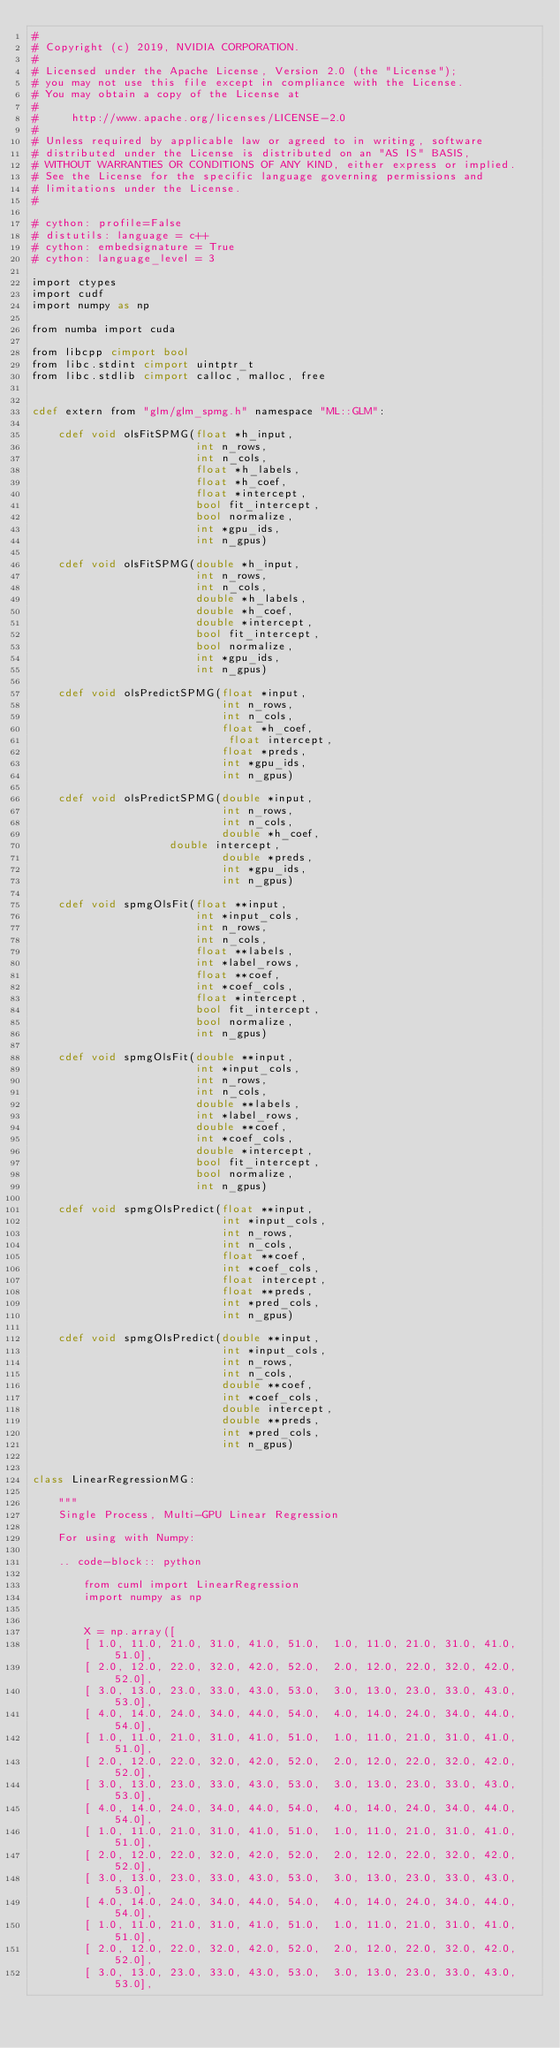<code> <loc_0><loc_0><loc_500><loc_500><_Cython_>#
# Copyright (c) 2019, NVIDIA CORPORATION.
#
# Licensed under the Apache License, Version 2.0 (the "License");
# you may not use this file except in compliance with the License.
# You may obtain a copy of the License at
#
#     http://www.apache.org/licenses/LICENSE-2.0
#
# Unless required by applicable law or agreed to in writing, software
# distributed under the License is distributed on an "AS IS" BASIS,
# WITHOUT WARRANTIES OR CONDITIONS OF ANY KIND, either express or implied.
# See the License for the specific language governing permissions and
# limitations under the License.
#

# cython: profile=False
# distutils: language = c++
# cython: embedsignature = True
# cython: language_level = 3

import ctypes
import cudf
import numpy as np

from numba import cuda

from libcpp cimport bool
from libc.stdint cimport uintptr_t
from libc.stdlib cimport calloc, malloc, free


cdef extern from "glm/glm_spmg.h" namespace "ML::GLM":

    cdef void olsFitSPMG(float *h_input,
                         int n_rows,
                         int n_cols,
                         float *h_labels,
                         float *h_coef,
                         float *intercept,
                         bool fit_intercept,
                         bool normalize,
                         int *gpu_ids,
                         int n_gpus)

    cdef void olsFitSPMG(double *h_input,
                         int n_rows,
                         int n_cols,
                         double *h_labels,
                         double *h_coef,
                         double *intercept,
                         bool fit_intercept,
                         bool normalize,
                         int *gpu_ids,
                         int n_gpus)

    cdef void olsPredictSPMG(float *input,
                             int n_rows,
                             int n_cols,
                             float *h_coef,
                              float intercept,
                             float *preds,
                             int *gpu_ids,
                             int n_gpus)

    cdef void olsPredictSPMG(double *input,
                             int n_rows,
                             int n_cols,
                             double *h_coef,
                     double intercept,
                             double *preds,
                             int *gpu_ids,
                             int n_gpus)

    cdef void spmgOlsFit(float **input,
                         int *input_cols,
                         int n_rows,
                         int n_cols,
                         float **labels,
                         int *label_rows,
                         float **coef,
                         int *coef_cols,
                         float *intercept,
                         bool fit_intercept,
                         bool normalize,
                         int n_gpus)

    cdef void spmgOlsFit(double **input,
                         int *input_cols,
                         int n_rows,
                         int n_cols,
                         double **labels,
                         int *label_rows,
                         double **coef,
                         int *coef_cols,
                         double *intercept,
                         bool fit_intercept,
                         bool normalize,
                         int n_gpus)

    cdef void spmgOlsPredict(float **input,
                             int *input_cols,
                             int n_rows,
                             int n_cols,
                             float **coef,
                             int *coef_cols,
                             float intercept,
                             float **preds,
                             int *pred_cols,
                             int n_gpus)

    cdef void spmgOlsPredict(double **input,
                             int *input_cols,
                             int n_rows,
                             int n_cols,
                             double **coef,
                             int *coef_cols,
                             double intercept,
                             double **preds,
                             int *pred_cols,
                             int n_gpus)


class LinearRegressionMG:

    """
    Single Process, Multi-GPU Linear Regression

    For using with Numpy:

    .. code-block:: python

        from cuml import LinearRegression
        import numpy as np


        X = np.array([
        [ 1.0, 11.0, 21.0, 31.0, 41.0, 51.0,  1.0, 11.0, 21.0, 31.0, 41.0, 51.0],
        [ 2.0, 12.0, 22.0, 32.0, 42.0, 52.0,  2.0, 12.0, 22.0, 32.0, 42.0, 52.0],
        [ 3.0, 13.0, 23.0, 33.0, 43.0, 53.0,  3.0, 13.0, 23.0, 33.0, 43.0, 53.0],
        [ 4.0, 14.0, 24.0, 34.0, 44.0, 54.0,  4.0, 14.0, 24.0, 34.0, 44.0, 54.0],
        [ 1.0, 11.0, 21.0, 31.0, 41.0, 51.0,  1.0, 11.0, 21.0, 31.0, 41.0, 51.0],
        [ 2.0, 12.0, 22.0, 32.0, 42.0, 52.0,  2.0, 12.0, 22.0, 32.0, 42.0, 52.0],
        [ 3.0, 13.0, 23.0, 33.0, 43.0, 53.0,  3.0, 13.0, 23.0, 33.0, 43.0, 53.0],
        [ 4.0, 14.0, 24.0, 34.0, 44.0, 54.0,  4.0, 14.0, 24.0, 34.0, 44.0, 54.0],
        [ 1.0, 11.0, 21.0, 31.0, 41.0, 51.0,  1.0, 11.0, 21.0, 31.0, 41.0, 51.0],
        [ 2.0, 12.0, 22.0, 32.0, 42.0, 52.0,  2.0, 12.0, 22.0, 32.0, 42.0, 52.0],
        [ 3.0, 13.0, 23.0, 33.0, 43.0, 53.0,  3.0, 13.0, 23.0, 33.0, 43.0, 53.0],
        [ 4.0, 14.0, 24.0, 34.0, 44.0, 54.0,  4.0, 14.0, 24.0, 34.0, 44.0, 54.0],
        [ 1.0, 11.0, 21.0, 31.0, 41.0, 51.0,  1.0, 11.0, 21.0, 31.0, 41.0, 51.0],
        [ 2.0, 12.0, 22.0, 32.0, 42.0, 52.0,  2.0, 12.0, 22.0, 32.0, 42.0, 52.0],
        [ 3.0, 13.0, 23.0, 33.0, 43.0, 53.0,  3.0, 13.0, 23.0, 33.0, 43.0, 53.0],</code> 